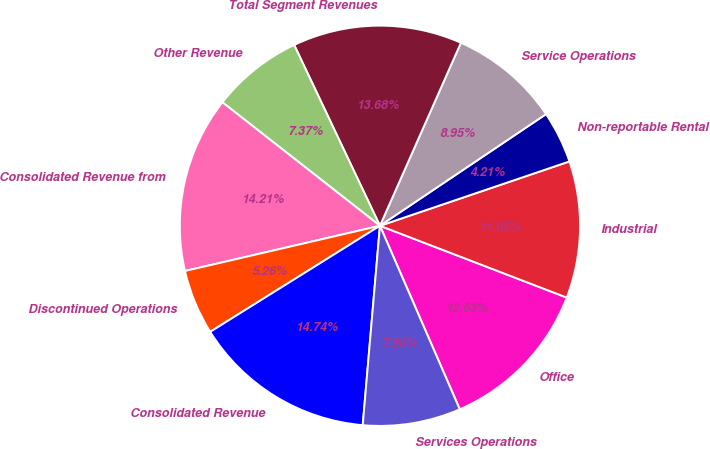Convert chart to OTSL. <chart><loc_0><loc_0><loc_500><loc_500><pie_chart><fcel>Office<fcel>Industrial<fcel>Non-reportable Rental<fcel>Service Operations<fcel>Total Segment Revenues<fcel>Other Revenue<fcel>Consolidated Revenue from<fcel>Discontinued Operations<fcel>Consolidated Revenue<fcel>Services Operations<nl><fcel>12.63%<fcel>11.05%<fcel>4.21%<fcel>8.95%<fcel>13.68%<fcel>7.37%<fcel>14.21%<fcel>5.26%<fcel>14.74%<fcel>7.9%<nl></chart> 